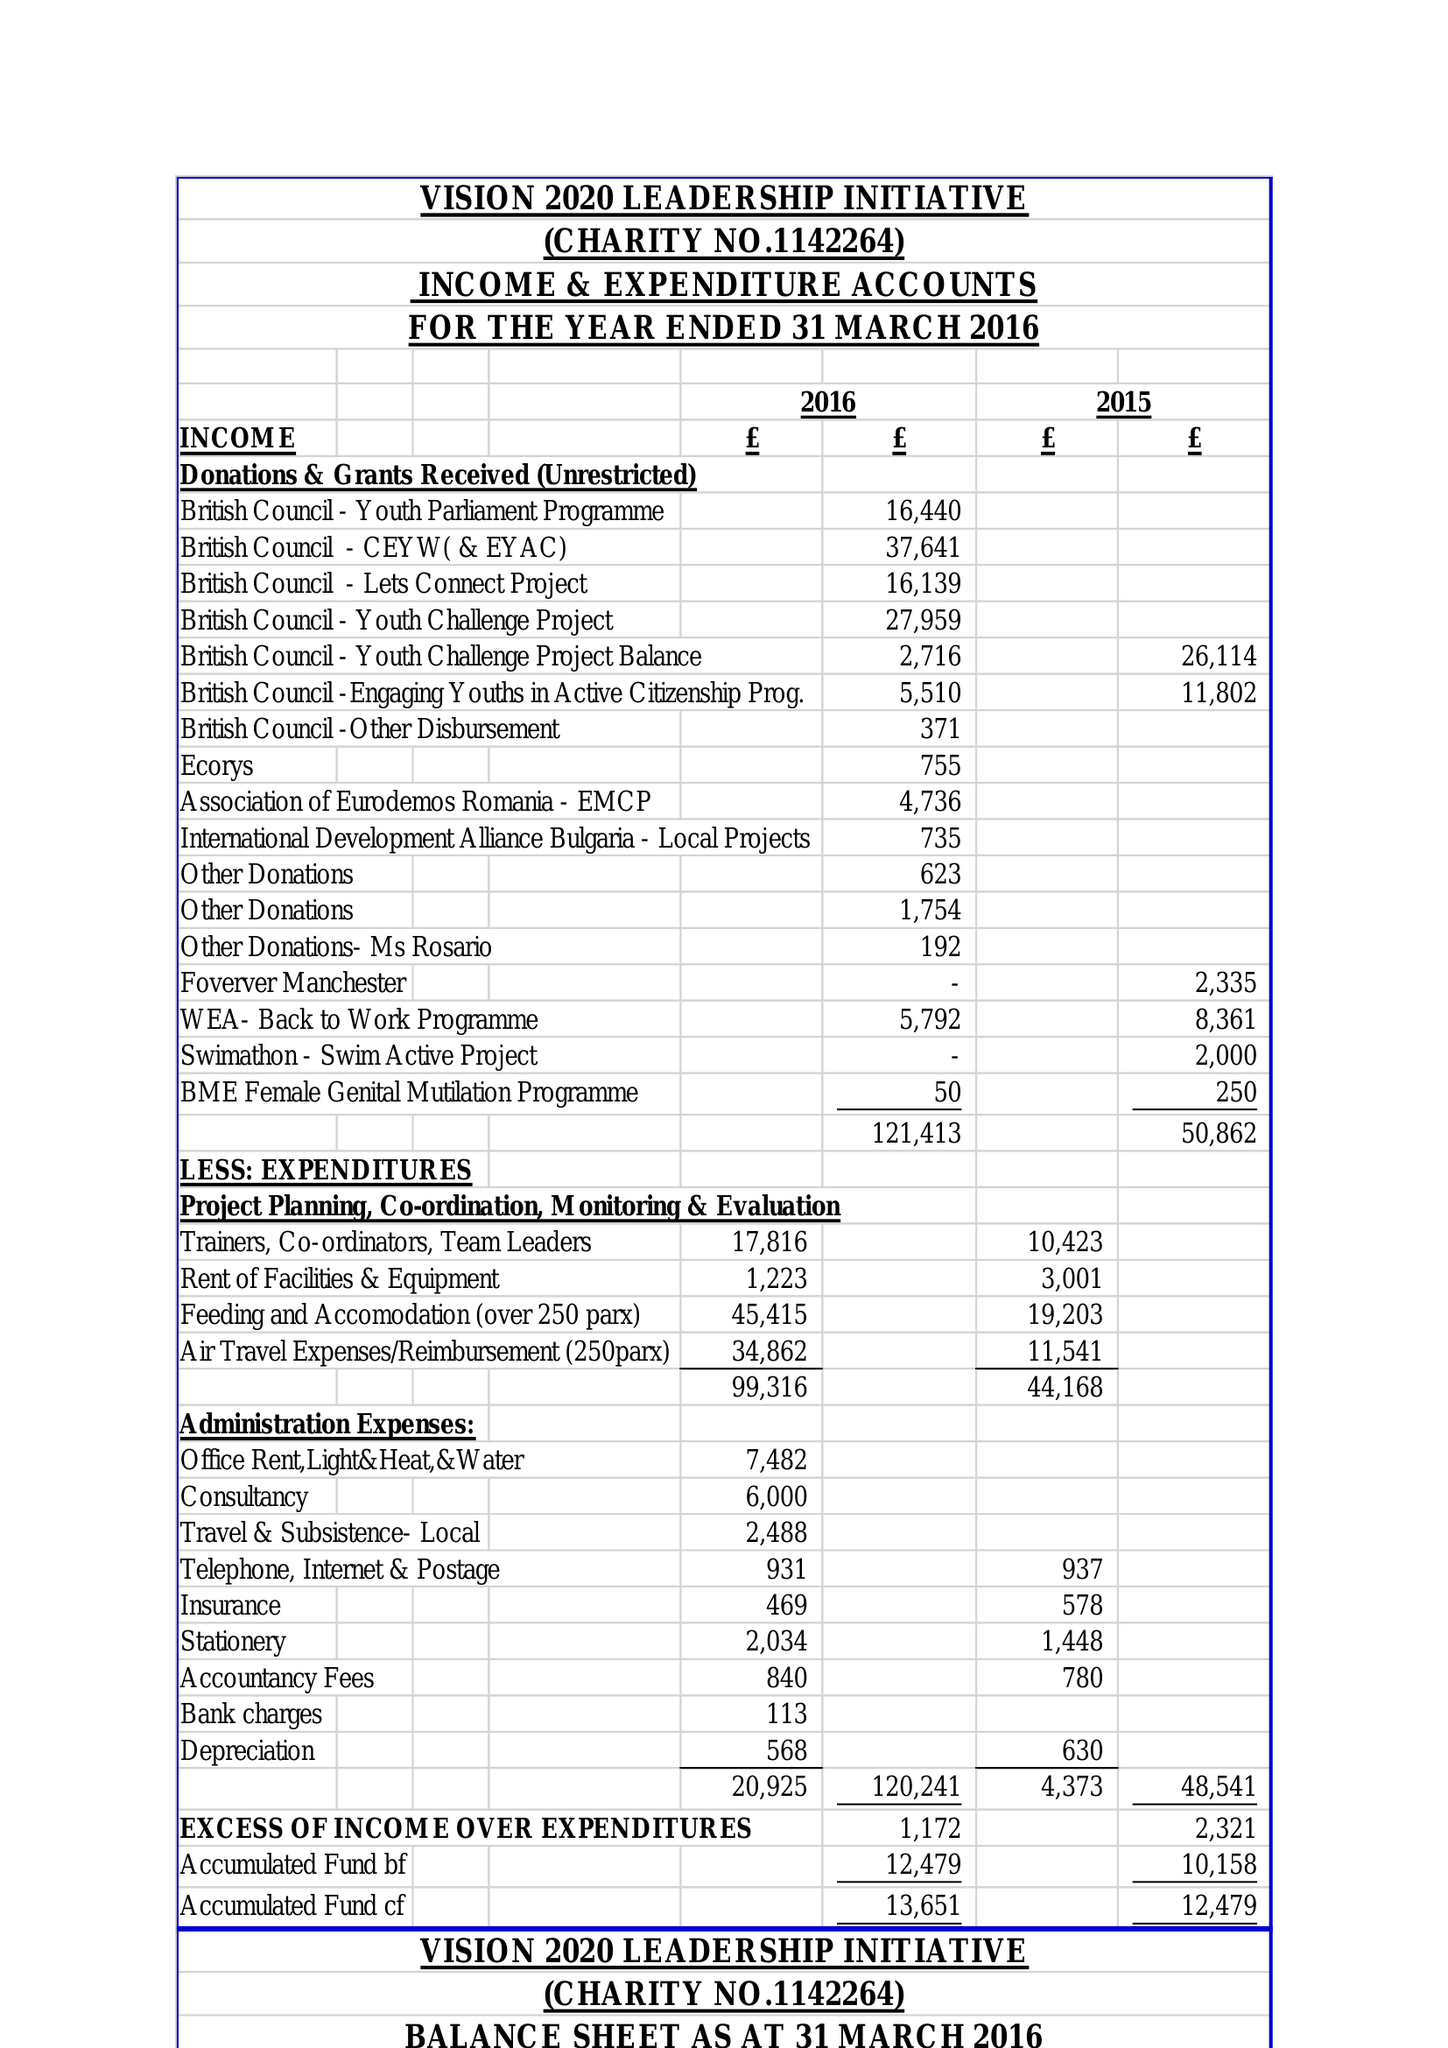What is the value for the income_annually_in_british_pounds?
Answer the question using a single word or phrase. 121413.00 